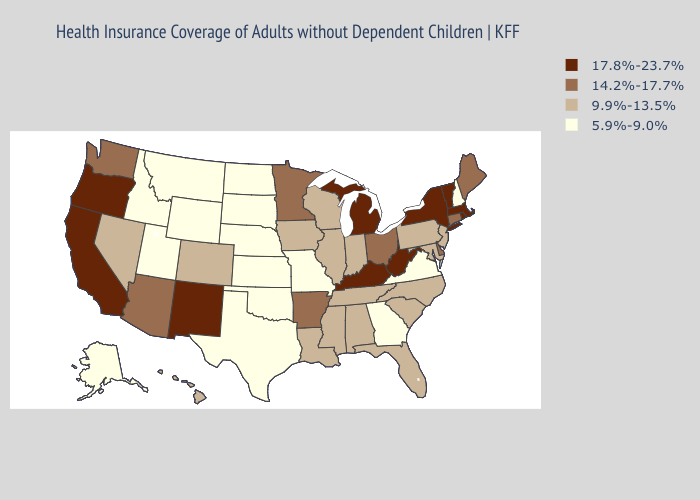Does Tennessee have the highest value in the South?
Keep it brief. No. What is the highest value in states that border Utah?
Give a very brief answer. 17.8%-23.7%. What is the lowest value in states that border Pennsylvania?
Be succinct. 9.9%-13.5%. What is the value of South Dakota?
Write a very short answer. 5.9%-9.0%. Which states have the highest value in the USA?
Quick response, please. California, Kentucky, Massachusetts, Michigan, New Mexico, New York, Oregon, Rhode Island, Vermont, West Virginia. Does the map have missing data?
Concise answer only. No. Among the states that border New York , which have the highest value?
Concise answer only. Massachusetts, Vermont. What is the value of New York?
Quick response, please. 17.8%-23.7%. Which states hav the highest value in the West?
Answer briefly. California, New Mexico, Oregon. What is the lowest value in the USA?
Write a very short answer. 5.9%-9.0%. What is the value of Idaho?
Short answer required. 5.9%-9.0%. Among the states that border Missouri , which have the lowest value?
Keep it brief. Kansas, Nebraska, Oklahoma. Name the states that have a value in the range 5.9%-9.0%?
Concise answer only. Alaska, Georgia, Idaho, Kansas, Missouri, Montana, Nebraska, New Hampshire, North Dakota, Oklahoma, South Dakota, Texas, Utah, Virginia, Wyoming. Does New York have a higher value than Oregon?
Give a very brief answer. No. Which states hav the highest value in the West?
Give a very brief answer. California, New Mexico, Oregon. 